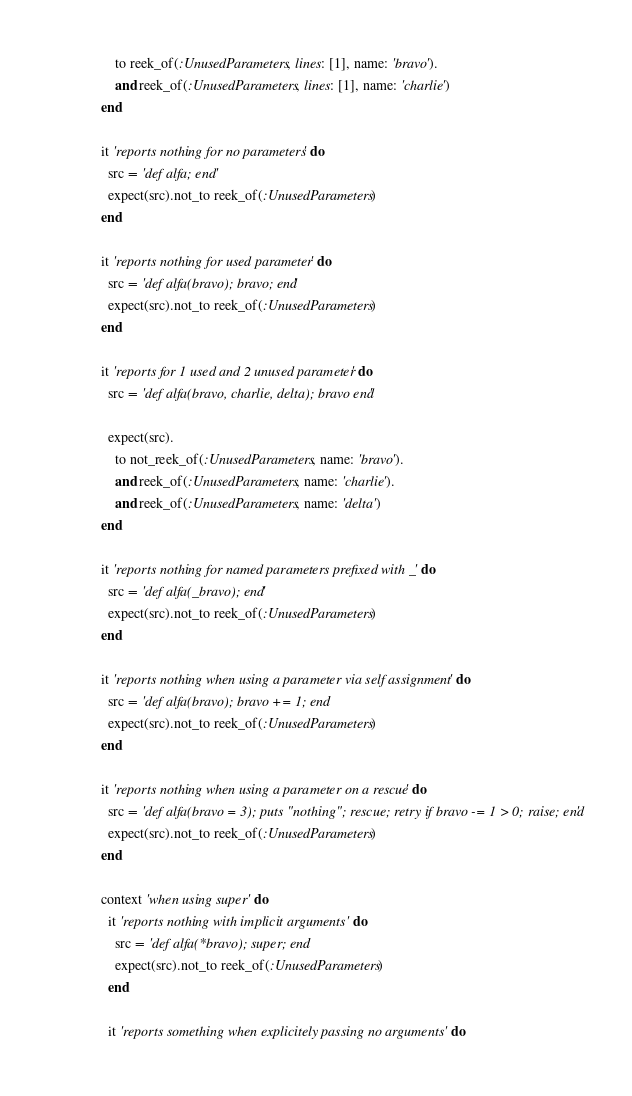Convert code to text. <code><loc_0><loc_0><loc_500><loc_500><_Ruby_>      to reek_of(:UnusedParameters, lines: [1], name: 'bravo').
      and reek_of(:UnusedParameters, lines: [1], name: 'charlie')
  end

  it 'reports nothing for no parameters' do
    src = 'def alfa; end'
    expect(src).not_to reek_of(:UnusedParameters)
  end

  it 'reports nothing for used parameter' do
    src = 'def alfa(bravo); bravo; end'
    expect(src).not_to reek_of(:UnusedParameters)
  end

  it 'reports for 1 used and 2 unused parameter' do
    src = 'def alfa(bravo, charlie, delta); bravo end'

    expect(src).
      to not_reek_of(:UnusedParameters, name: 'bravo').
      and reek_of(:UnusedParameters, name: 'charlie').
      and reek_of(:UnusedParameters, name: 'delta')
  end

  it 'reports nothing for named parameters prefixed with _' do
    src = 'def alfa(_bravo); end'
    expect(src).not_to reek_of(:UnusedParameters)
  end

  it 'reports nothing when using a parameter via self assignment' do
    src = 'def alfa(bravo); bravo += 1; end'
    expect(src).not_to reek_of(:UnusedParameters)
  end

  it 'reports nothing when using a parameter on a rescue' do
    src = 'def alfa(bravo = 3); puts "nothing"; rescue; retry if bravo -= 1 > 0; raise; end'
    expect(src).not_to reek_of(:UnusedParameters)
  end

  context 'when using super' do
    it 'reports nothing with implicit arguments' do
      src = 'def alfa(*bravo); super; end'
      expect(src).not_to reek_of(:UnusedParameters)
    end

    it 'reports something when explicitely passing no arguments' do</code> 